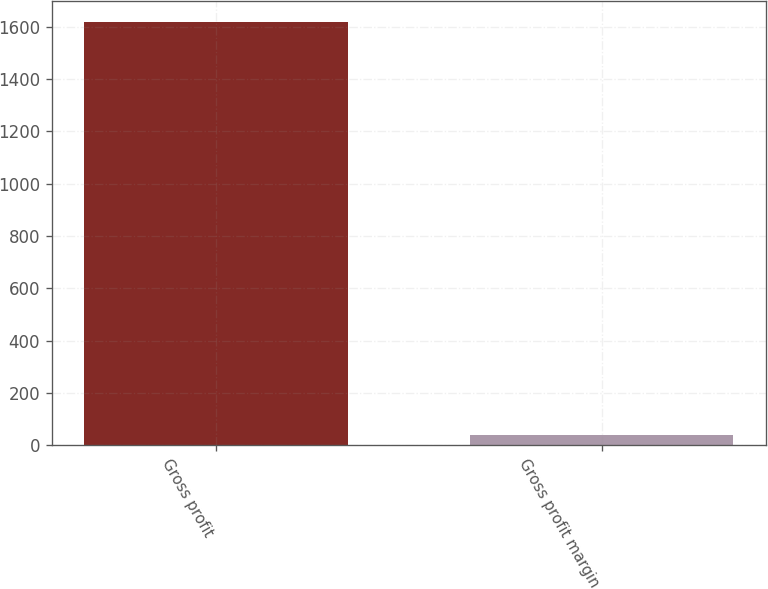Convert chart to OTSL. <chart><loc_0><loc_0><loc_500><loc_500><bar_chart><fcel>Gross profit<fcel>Gross profit margin<nl><fcel>1617.8<fcel>40.3<nl></chart> 